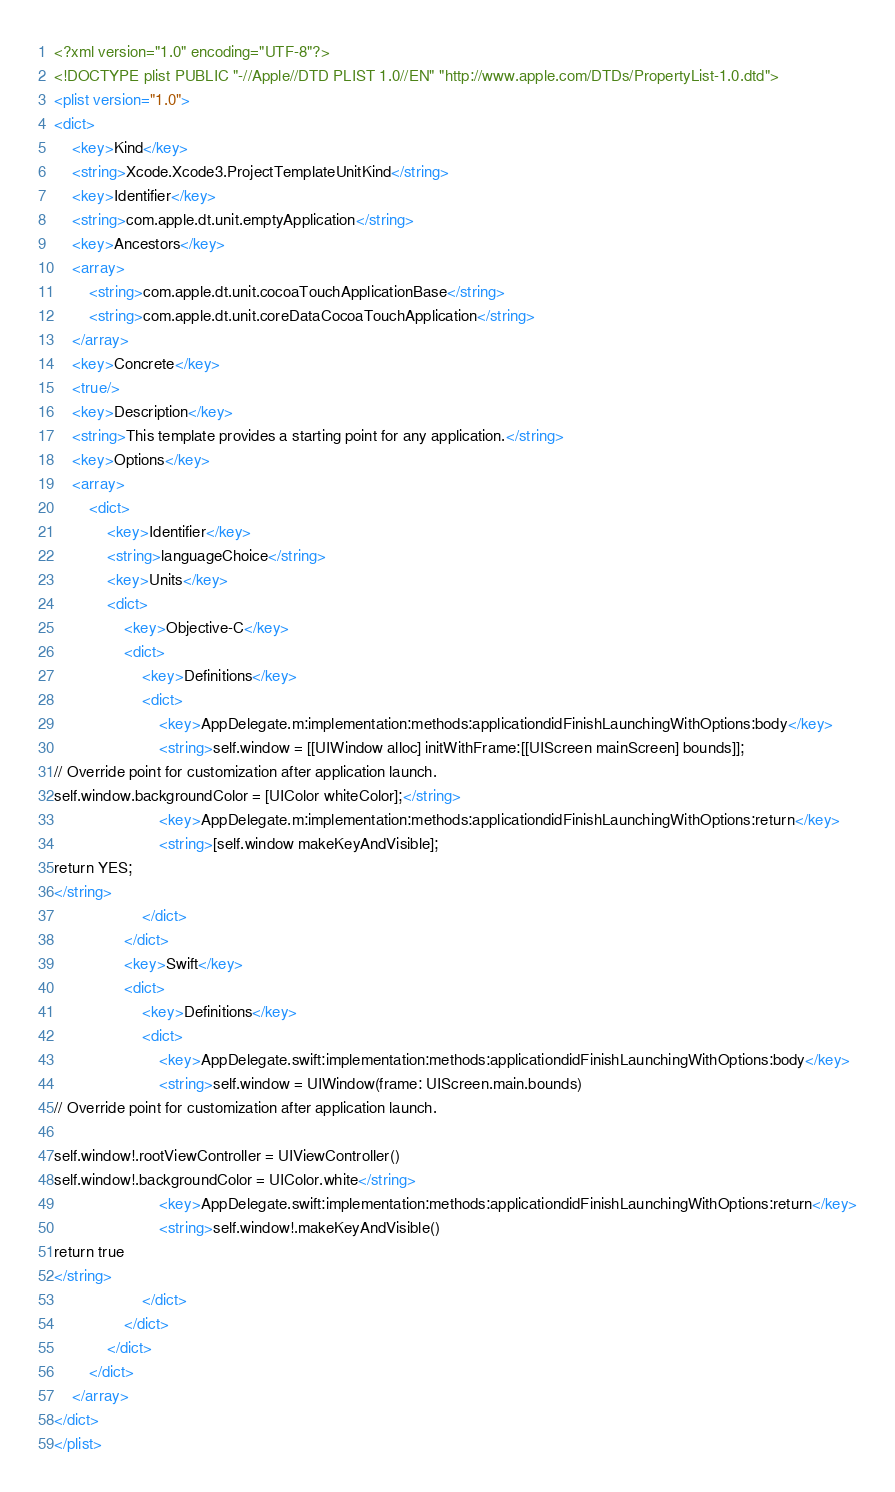<code> <loc_0><loc_0><loc_500><loc_500><_XML_><?xml version="1.0" encoding="UTF-8"?>
<!DOCTYPE plist PUBLIC "-//Apple//DTD PLIST 1.0//EN" "http://www.apple.com/DTDs/PropertyList-1.0.dtd">
<plist version="1.0">
<dict>
	<key>Kind</key>
	<string>Xcode.Xcode3.ProjectTemplateUnitKind</string>
	<key>Identifier</key>
	<string>com.apple.dt.unit.emptyApplication</string>
	<key>Ancestors</key>
	<array>
		<string>com.apple.dt.unit.cocoaTouchApplicationBase</string>
		<string>com.apple.dt.unit.coreDataCocoaTouchApplication</string>
	</array>
	<key>Concrete</key>
	<true/>
	<key>Description</key>
	<string>This template provides a starting point for any application.</string>
	<key>Options</key>
	<array>
		<dict>
			<key>Identifier</key>
			<string>languageChoice</string>
			<key>Units</key>
			<dict>
				<key>Objective-C</key>
				<dict>
					<key>Definitions</key>
					<dict>
						<key>AppDelegate.m:implementation:methods:applicationdidFinishLaunchingWithOptions:body</key>
						<string>self.window = [[UIWindow alloc] initWithFrame:[[UIScreen mainScreen] bounds]];
// Override point for customization after application launch.
self.window.backgroundColor = [UIColor whiteColor];</string>
						<key>AppDelegate.m:implementation:methods:applicationdidFinishLaunchingWithOptions:return</key>
						<string>[self.window makeKeyAndVisible];
return YES;
</string>
					</dict>
				</dict>
				<key>Swift</key>
				<dict>
					<key>Definitions</key>
					<dict>
						<key>AppDelegate.swift:implementation:methods:applicationdidFinishLaunchingWithOptions:body</key>
						<string>self.window = UIWindow(frame: UIScreen.main.bounds)
// Override point for customization after application launch.

self.window!.rootViewController = UIViewController()
self.window!.backgroundColor = UIColor.white</string>
						<key>AppDelegate.swift:implementation:methods:applicationdidFinishLaunchingWithOptions:return</key>
						<string>self.window!.makeKeyAndVisible()
return true
</string>
					</dict>
				</dict>
			</dict>
		</dict>
	</array>
</dict>
</plist>
</code> 